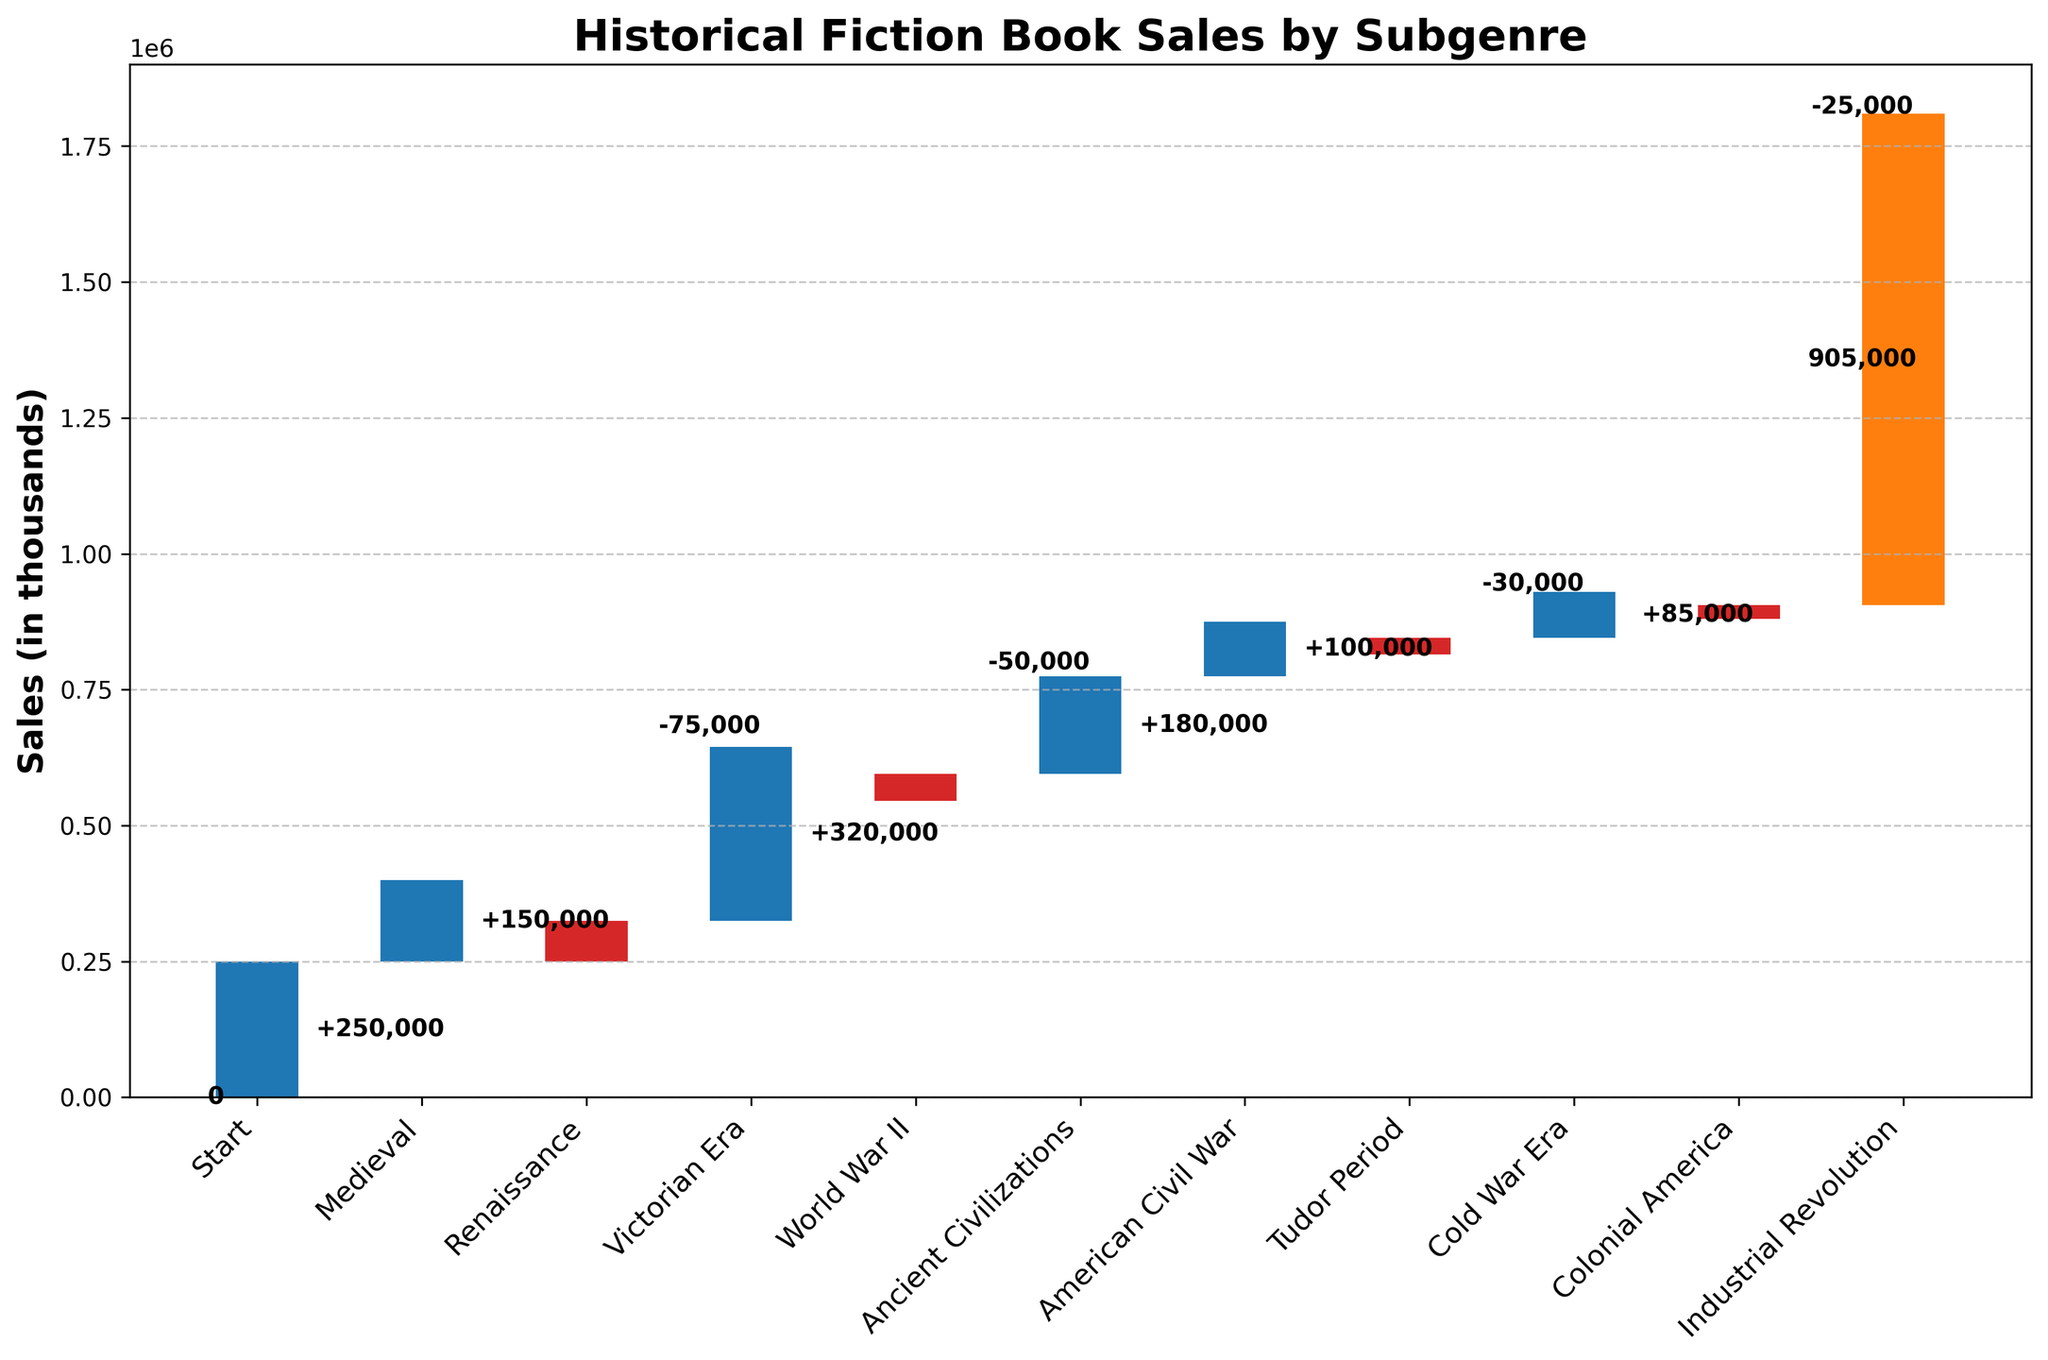What is the title of the chart? The title is located at the top of the chart and is typically in a larger and bolder font. Reading the title directly from the chart helps understand its context immediately.
Answer: Historical Fiction Book Sales by Subgenre What is the total sales value depicted on the chart? The total sales value is represented by the last bar, which usually sums up the cumulative contributions of all bars before it. In this chart, it is shown at the end of the sequence.
Answer: 905,000 Which subgenre contributed negatively the most to the sales? The subgenre with the most negative contribution will have the longest red bar pointing downwards. By comparing the lengths of these bars, we can identify it.
Answer: Victorian Era What's the cumulative sales value after the "World War II" subgenre? To find this, add the starting value to the contributions up to and including "World War II". Start from 0, add Medieval, Renaissance, Victorian Era, and World War II values sequentially. 0 + 250,000 + 150,000 - 75,000 + 320,000 = 645,000.
Answer: 645,000 How many subgenres showed a positive increment in sales? Count the number of blue bars in the chart, as these represent positive increments in the Waterfall Chart.
Answer: 6 What is the sales contribution from the "American Civil War" subgenre? Look for the height of the bar labeled "American Civil War" and read its value directly from the chart.
Answer: 180,000 By how much did the "Ancient Civilizations" subgenre reduce the total sales? Refer to the bar that represents "Ancient Civilizations" which is a red bar towards the lower part of the chart, and read its value.
Answer: -50,000 Which subgenre has the smallest positive impact on sales? Identify the smallest blue bar in terms of height among the positive contributors and read the corresponding label.
Answer: Colonial America What's the combined sales value of the "Renaissance" and "World War II" subgenres? Add the individual sales values of these two subgenres together. Renaissance is 150,000 and World War II is 320,000. 150,000 + 320,000 = 470,000.
Answer: 470,000 What's the net change in sales after the "Victorian Era" subgenre? To find the net change, calculate the sum of all contributions up to and including the "Victorian Era". Start from 0 and sum the values of Medieval, Renaissance, and Victorian Era sequentially. 0 + 250,000 + 150,000 - 75,000 = 325,000.
Answer: 325,000 